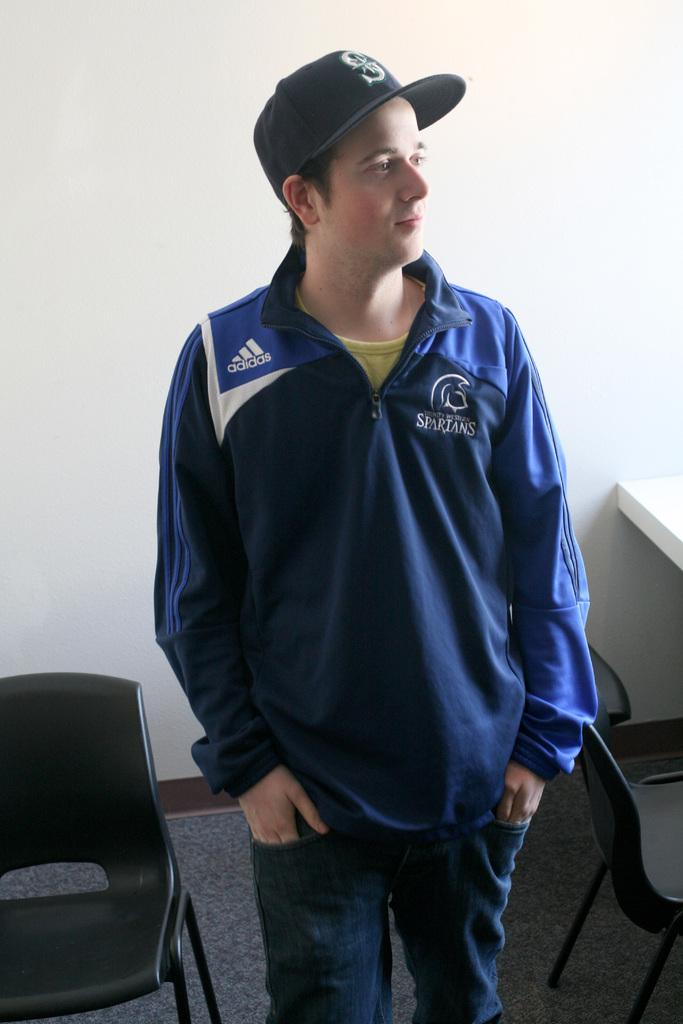What is the main subject of the image? The main subject of the image is a man. Can you describe the man's clothing? The man is wearing a blue jacket and black jeans. What type of headwear is the man wearing? The man is wearing a cap. What is the man doing in the image? The man is looking somewhere, looking at something. What type of furniture is present in the image? There are chairs and at least one desk in the image. What is the setting of the image? The setting appears to be a room. What type of fowl can be seen celebrating the man's birthday in the image? There is no fowl present in the image, and there is no indication of a birthday celebration. 